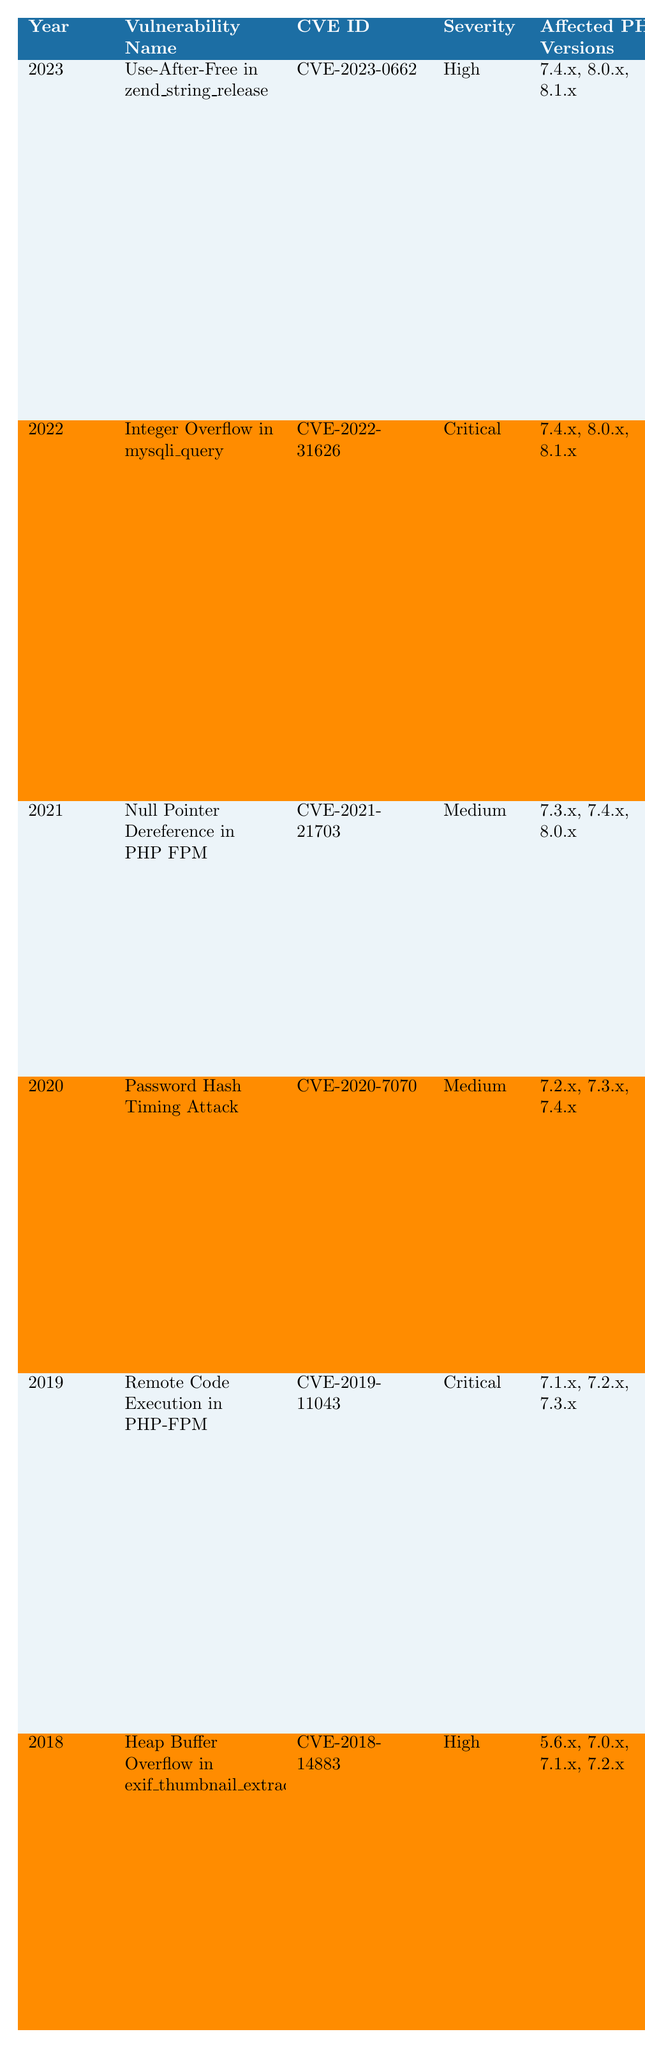What was the most severe vulnerability reported in 2022? The table shows that the most severe vulnerability in 2022 is the "Integer Overflow in mysqli_query," which has a severity rating of "Critical."
Answer: Critical How many vulnerabilities affected PHP versions that are lower than 7.3.x? The table indicates that all vulnerabilities listed are related to PHP versions 7.3.x or higher, with none affecting versions lower than that. Therefore, the count is zero.
Answer: 0 Which vulnerability was discovered in 2020, and what was its severity level? According to the table, the vulnerability discovered in 2020 is the "Password Hash Timing Attack," which has a severity level of "Medium."
Answer: Medium What is the trend in the severity of vulnerabilities from 2018 to 2023? By examining the table, we see that the severity levels vary: High in 2018, Critical in 2019, Medium in 2020 and 2021, Critical in 2022, and High in 2023. The trend fluctuates rather than having a consistent increase or decrease.
Answer: Fluctuates Is there any vulnerability that affects PHP version 7.1.x? The table shows that “Remote Code Execution in PHP-FPM” and “Heap Buffer Overflow in exif_thumbnail_extract” affect PHP version 7.1.x, so the answer is yes.
Answer: Yes What are the possible affected PHP versions for the vulnerability listed in 2021? The vulnerability in 2021, "Null Pointer Dereference in PHP FPM," affects PHP versions 7.3.x, 7.4.x, and 8.0.x as shown in the table.
Answer: 7.3.x, 7.4.x, 8.0.x How many unique CVE IDs are listed for vulnerabilities discovered between 2019 and 2021? The table lists three vulnerabilities in that timeframe: CVE-2019-11043, CVE-2020-7070, and CVE-2021-21703, resulting in three unique CVE IDs.
Answer: 3 Which year had vulnerabilities that both allowed remote code execution? The years 2019 ("Remote Code Execution in PHP-FPM") and 2023 ("Use-After-Free in zend_string_release") both had vulnerabilities allowing remote code execution.
Answer: 2019 and 2023 What is the difference in severity level from the least severe to the most severe vulnerability in the table? The least severe vulnerability is rated as "Medium," and the most severe vulnerabilities are rated "Critical." The difference in severity levels is thus 2 levels ("Medium" to "Critical").
Answer: 2 levels Which vulnerability was introduced in the last year available in the table, and what is its description? The table shows that in 2023, the vulnerability is "Use-After-Free in zend_string_release," which describes memory corruption leading to potential remote code execution.
Answer: Memory corruption leading to potential remote code execution Which years had vulnerabilities rated as "High"? The years with vulnerabilities rated as "High" are 2018 and 2023, with their respective vulnerabilities being "Heap Buffer Overflow in exif_thumbnail_extract" and "Use-After-Free in zend_string_release."
Answer: 2018 and 2023 